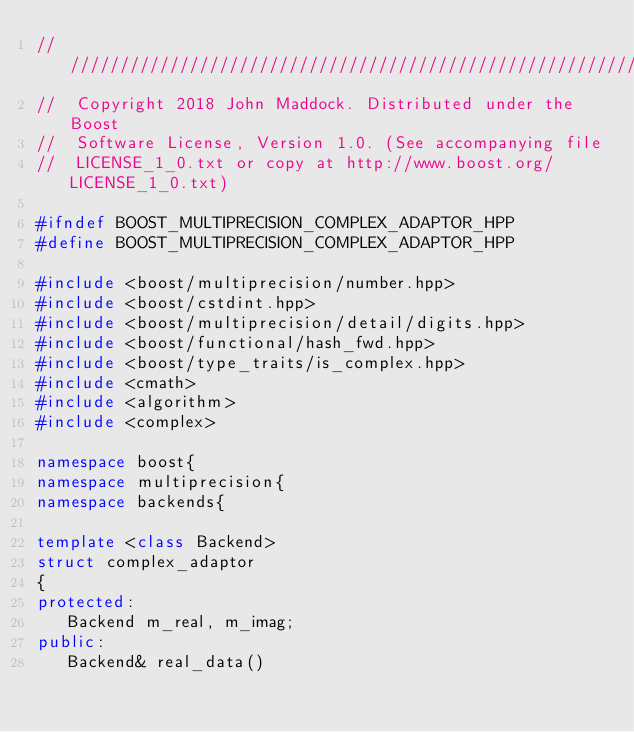Convert code to text. <code><loc_0><loc_0><loc_500><loc_500><_C++_>///////////////////////////////////////////////////////////////////////////////
//  Copyright 2018 John Maddock. Distributed under the Boost
//  Software License, Version 1.0. (See accompanying file
//  LICENSE_1_0.txt or copy at http://www.boost.org/LICENSE_1_0.txt)

#ifndef BOOST_MULTIPRECISION_COMPLEX_ADAPTOR_HPP
#define BOOST_MULTIPRECISION_COMPLEX_ADAPTOR_HPP

#include <boost/multiprecision/number.hpp>
#include <boost/cstdint.hpp>
#include <boost/multiprecision/detail/digits.hpp>
#include <boost/functional/hash_fwd.hpp>
#include <boost/type_traits/is_complex.hpp>
#include <cmath>
#include <algorithm>
#include <complex>

namespace boost{
namespace multiprecision{
namespace backends{

template <class Backend>
struct complex_adaptor
{
protected:
   Backend m_real, m_imag;
public:
   Backend& real_data() </code> 